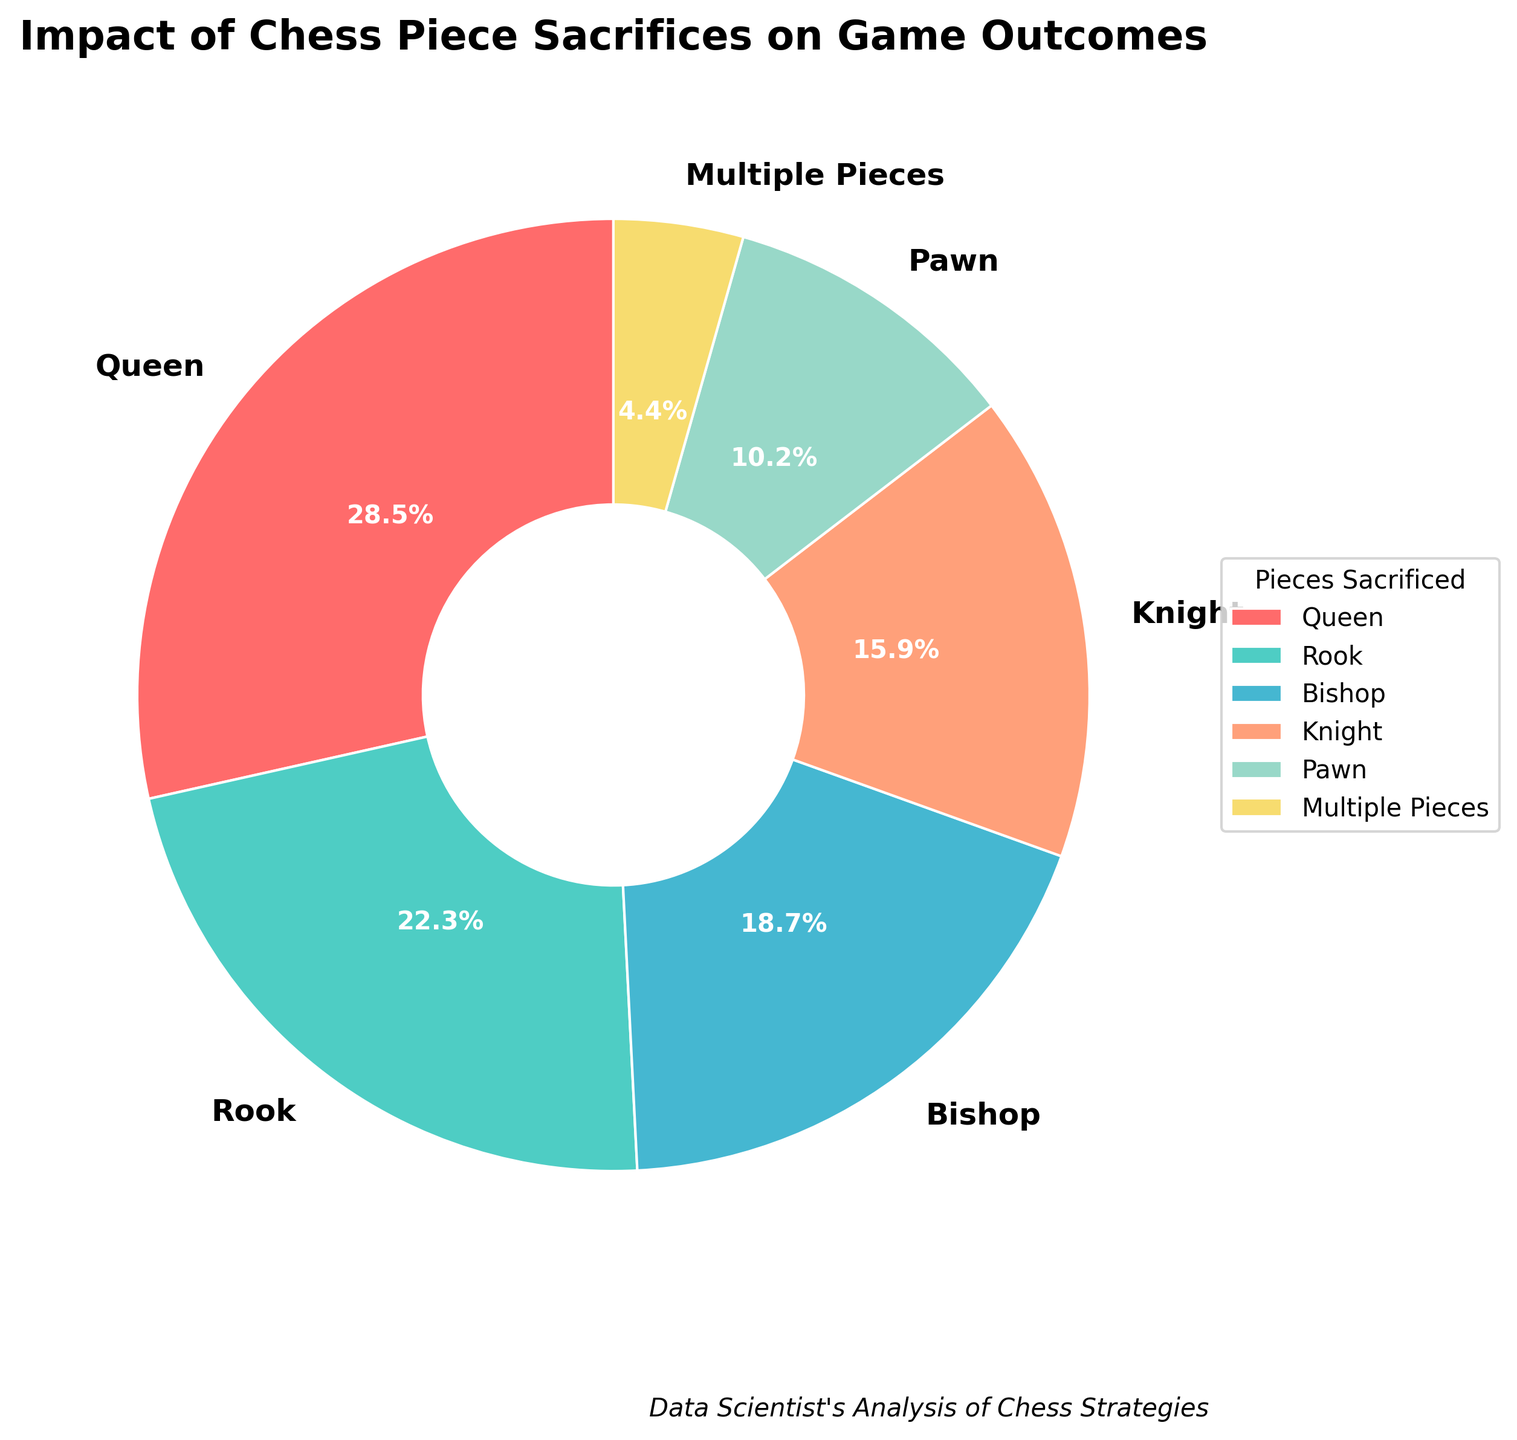Which chess piece sacrifice leads to the highest percentage of games won? The Queen is the piece that, when sacrificed, results in the highest percentage of games won. According to the chart, sacrificing the Queen leads to a win rate of 28.5%.
Answer: Queen What is the total percentage of games won when the Bishop and Knight are sacrificed? To find the total percentage, add the win percentages of Bishop and Knight: 18.7% (Bishop) + 15.9% (Knight) = 34.6%.
Answer: 34.6% Which piece color-coded in light blue has a significant impact on the game outcome, and what is its win percentage? The Rook is color-coded in light blue and has a significant impact on game outcomes with a win percentage of 22.3%.
Answer: Rook, 22.3% How does the win rate from sacrificing multiple pieces compare to sacrificing only the Pawn? Compare the win rates: Sacrificing multiple pieces leads to 4.4% wins, whereas sacrificing just the Pawn results in a 10.2% win rate. Sacrificing only the Pawn has a higher win rate than sacrificing multiple pieces.
Answer: Sacrificing only the Pawn has a higher win rate What is the difference in win percentage between sacrificing the Queen and the Knight? To find the difference, subtract the Knight's win percentage from the Queen's: 28.5% (Queen) - 15.9% (Knight) = 12.6%.
Answer: 12.6% If the total win percentage is summed up for all pieces sacrificed, what would it be? Sum the percentages for all pieces sacrificed: 28.5% (Queen) + 22.3% (Rook) + 18.7% (Bishop) + 15.9% (Knight) + 10.2% (Pawn) + 4.4% (Multiple Pieces) = 100%.
Answer: 100% Which sacrifice yields an almost double win rate compared to the Pawn? Compare the win percentages: the Rook with 22.3% win rate is slightly more than double compared to the Pawn's 10.2%, but it is still the closest to double among the pieces listed.
Answer: Rook Out of the given sacrifices, which one has the lowest impact on game outcomes? The category 'Multiple Pieces' with a win rate of 4.4% has the lowest impact on game outcomes when sacrificed.
Answer: Multiple Pieces What is the cumulative win rate for sacrificing either a Queen, Rook, or Bishop? To find the cumulative win rate, sum the win percentages of the Queen, Rook, and Bishop: 28.5% (Queen) + 22.3% (Rook) + 18.7% (Bishop) = 69.5%.
Answer: 69.5% 